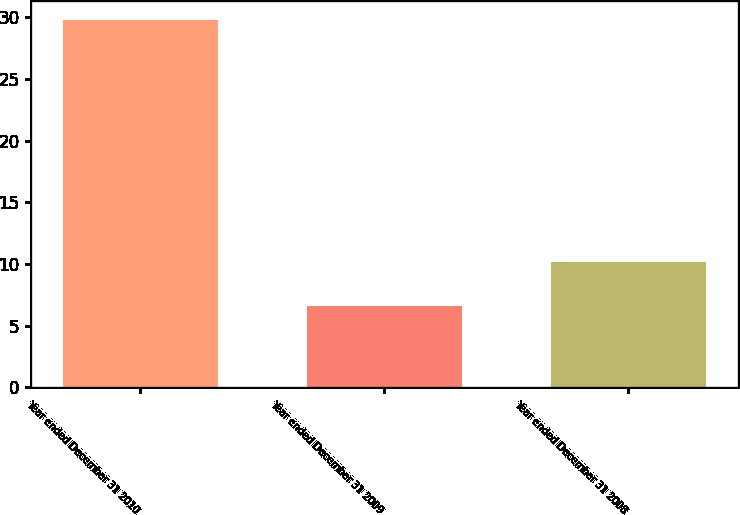Convert chart to OTSL. <chart><loc_0><loc_0><loc_500><loc_500><bar_chart><fcel>Year ended December 31 2010<fcel>Year ended December 31 2009<fcel>Year ended December 31 2008<nl><fcel>29.8<fcel>6.6<fcel>10.2<nl></chart> 